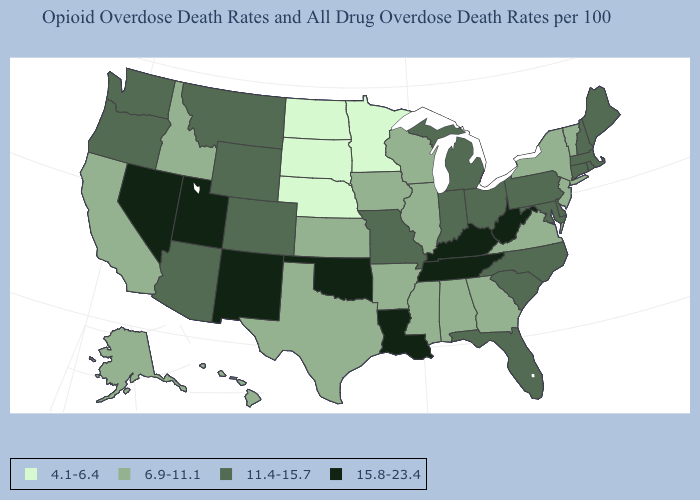What is the value of North Dakota?
Quick response, please. 4.1-6.4. Among the states that border Texas , which have the highest value?
Give a very brief answer. Louisiana, New Mexico, Oklahoma. Does Wisconsin have the lowest value in the USA?
Concise answer only. No. What is the value of California?
Concise answer only. 6.9-11.1. Name the states that have a value in the range 15.8-23.4?
Quick response, please. Kentucky, Louisiana, Nevada, New Mexico, Oklahoma, Tennessee, Utah, West Virginia. What is the value of Oregon?
Write a very short answer. 11.4-15.7. What is the value of Kentucky?
Concise answer only. 15.8-23.4. What is the lowest value in states that border Kentucky?
Be succinct. 6.9-11.1. Name the states that have a value in the range 4.1-6.4?
Short answer required. Minnesota, Nebraska, North Dakota, South Dakota. What is the value of Georgia?
Keep it brief. 6.9-11.1. Among the states that border Montana , does South Dakota have the lowest value?
Short answer required. Yes. Among the states that border Missouri , does Oklahoma have the highest value?
Answer briefly. Yes. Does the first symbol in the legend represent the smallest category?
Keep it brief. Yes. What is the value of South Dakota?
Be succinct. 4.1-6.4. Among the states that border New York , does Massachusetts have the highest value?
Give a very brief answer. Yes. 